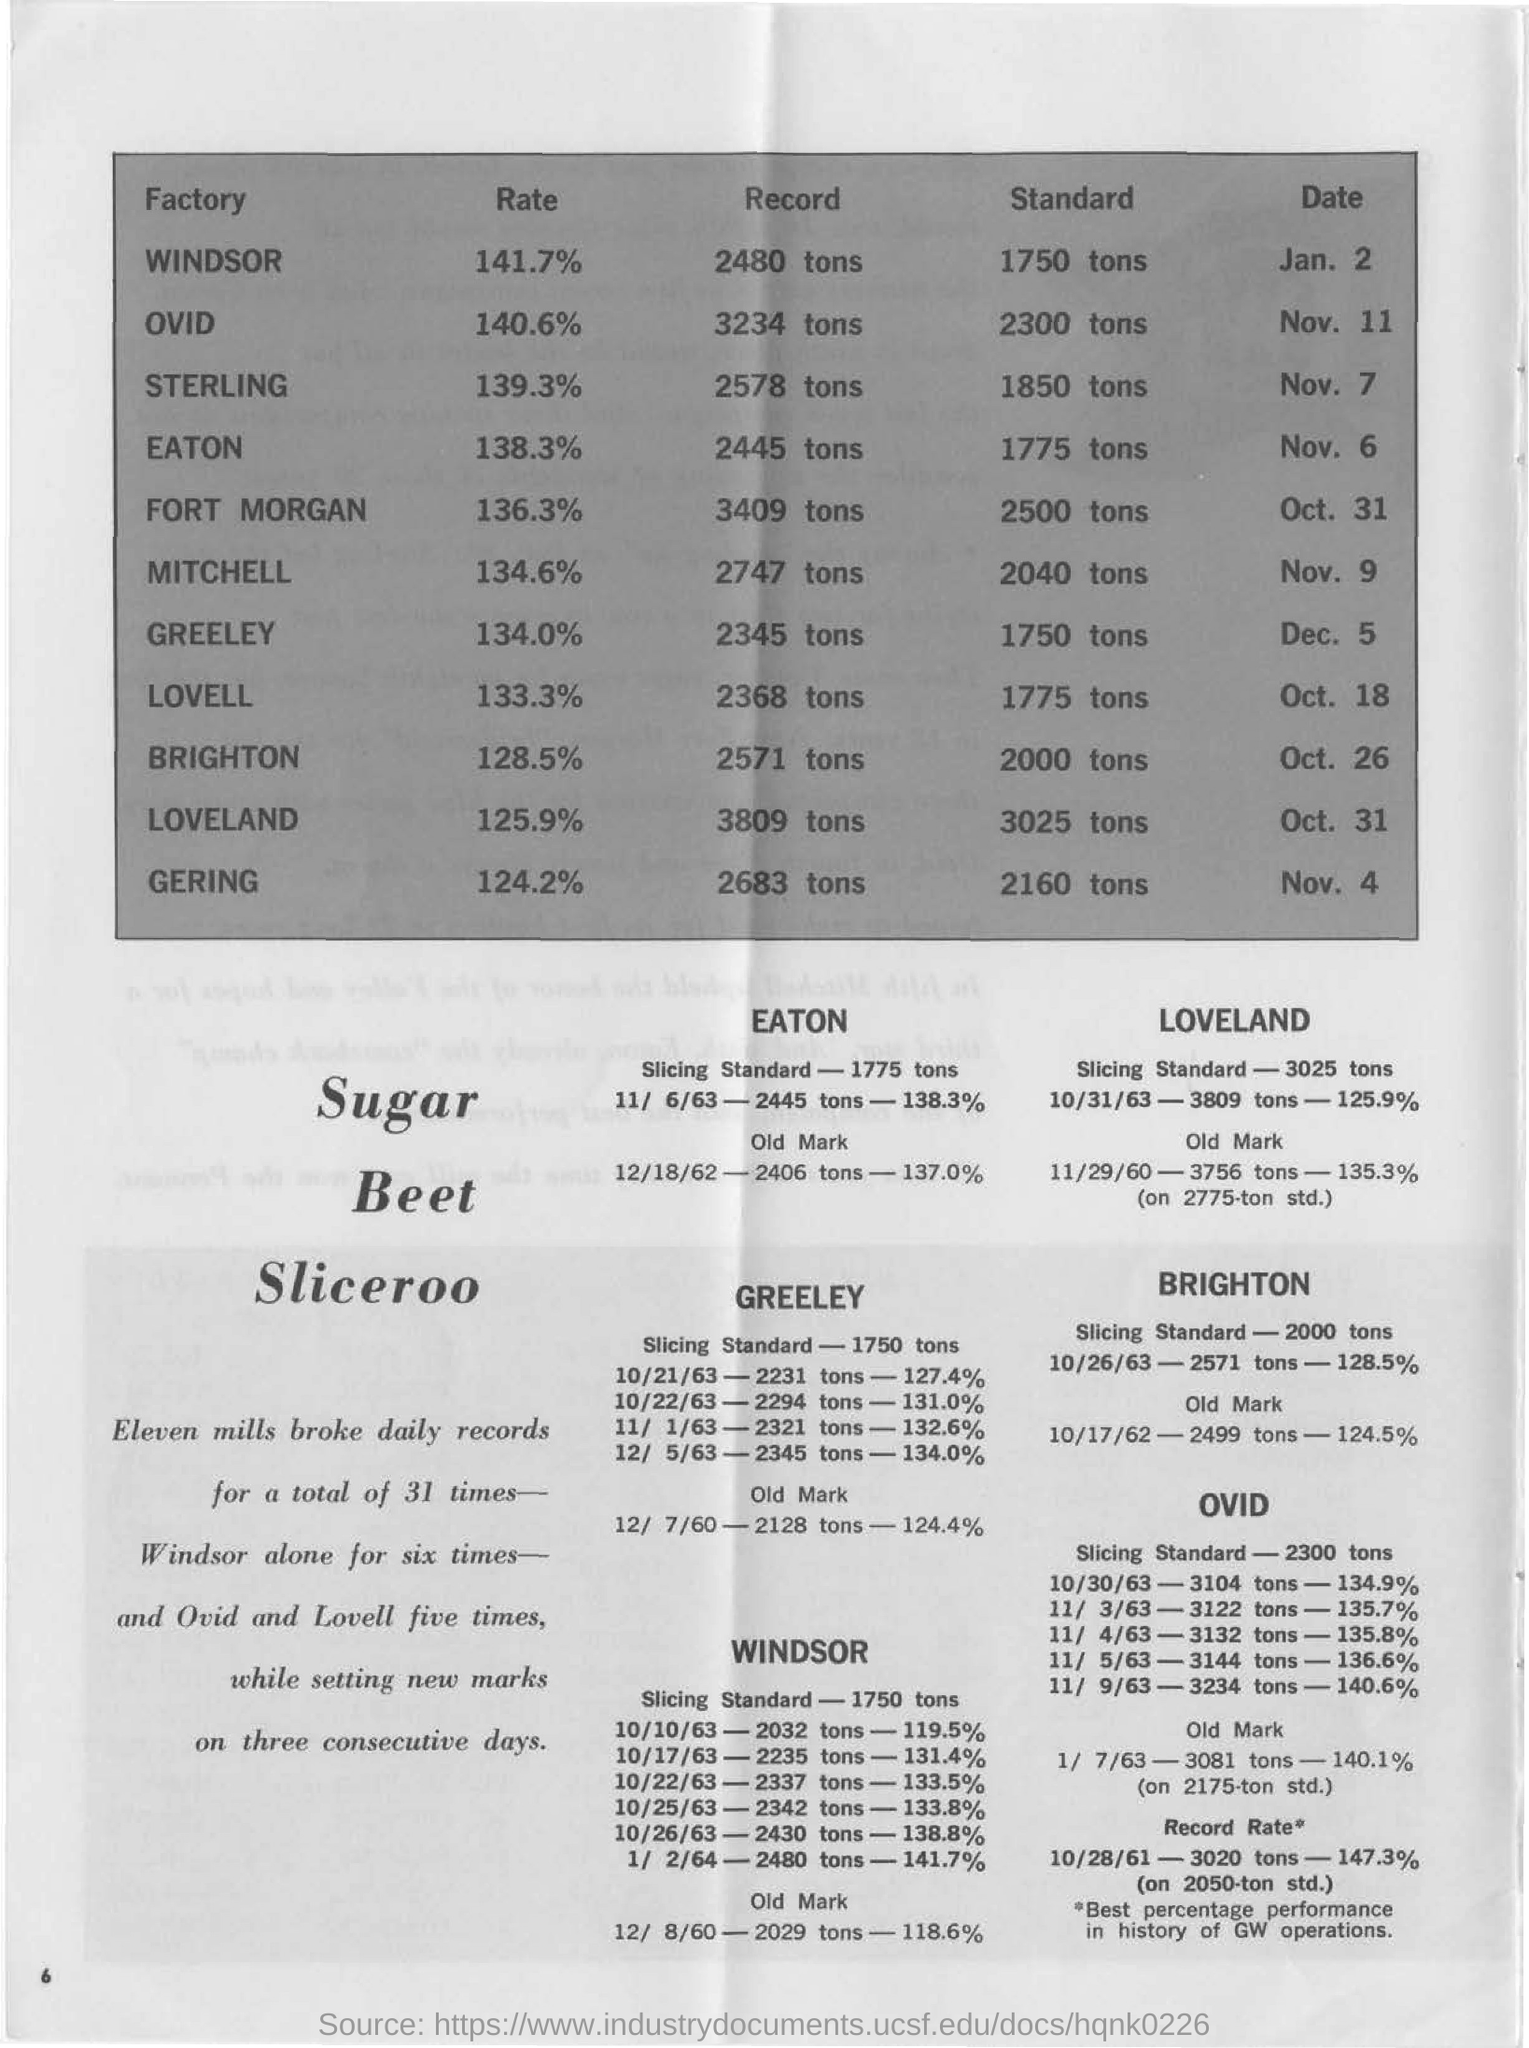Specify some key components in this picture. On the Lovell factory, the date is currently October 18th. The date on the OVID "factory" is November 11. On the Windsor 'factory', the date is currently January 2nd. The standard on the Gering "factory" is 2160 tons. The standard at the Windsor factory is 1750 tons. 